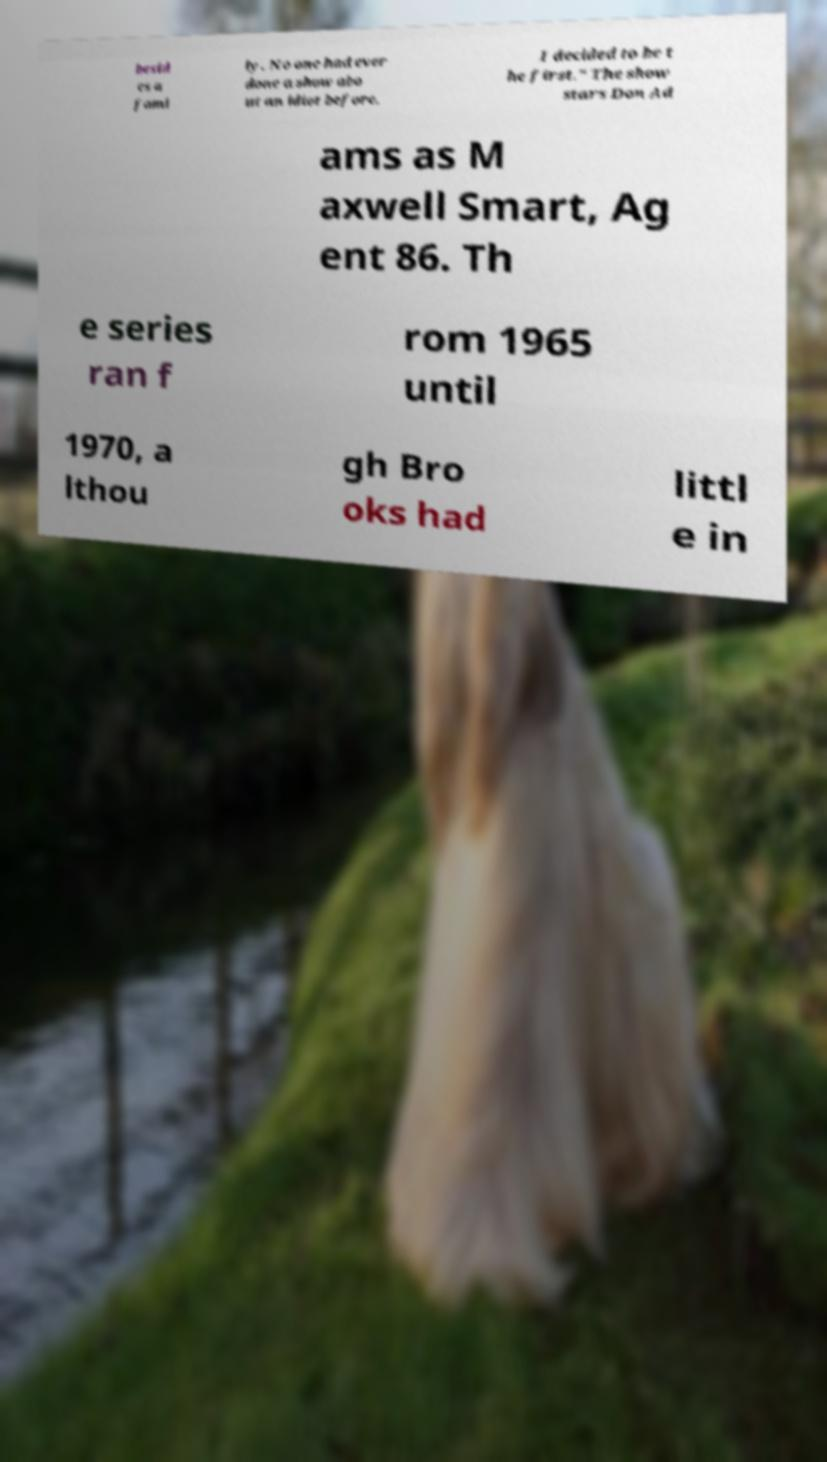For documentation purposes, I need the text within this image transcribed. Could you provide that? besid es a fami ly. No one had ever done a show abo ut an idiot before. I decided to be t he first." The show stars Don Ad ams as M axwell Smart, Ag ent 86. Th e series ran f rom 1965 until 1970, a lthou gh Bro oks had littl e in 